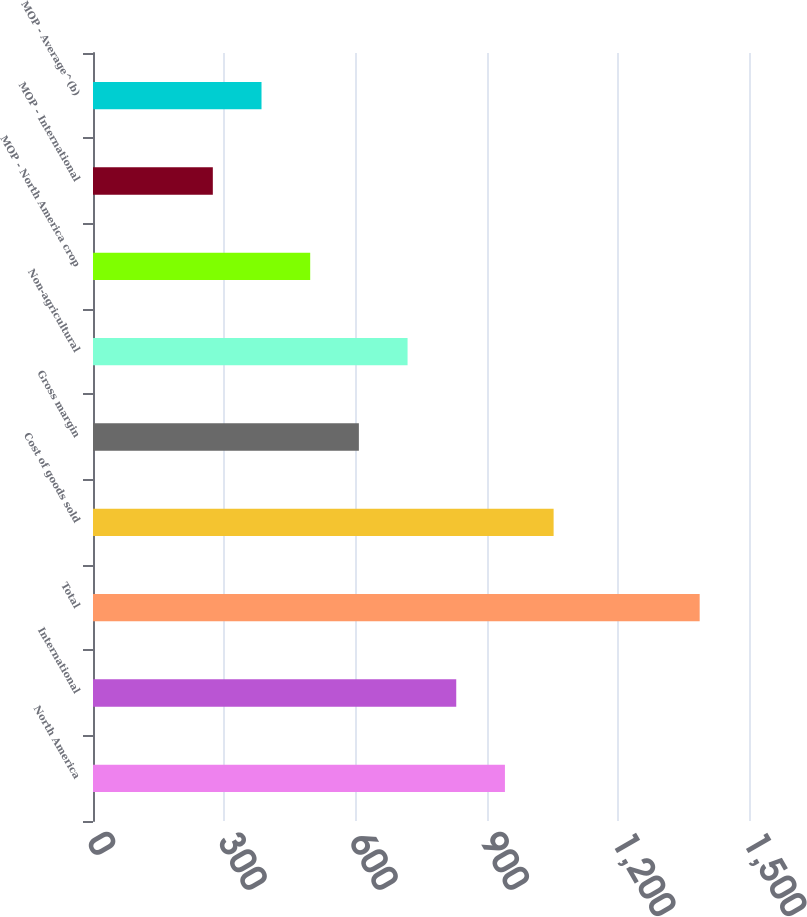Convert chart. <chart><loc_0><loc_0><loc_500><loc_500><bar_chart><fcel>North America<fcel>International<fcel>Total<fcel>Cost of goods sold<fcel>Gross margin<fcel>Non-agricultural<fcel>MOP - North America crop<fcel>MOP - International<fcel>MOP - Average^(b)<nl><fcel>941.92<fcel>830.6<fcel>1387.2<fcel>1053.24<fcel>607.96<fcel>719.28<fcel>496.64<fcel>274<fcel>385.32<nl></chart> 